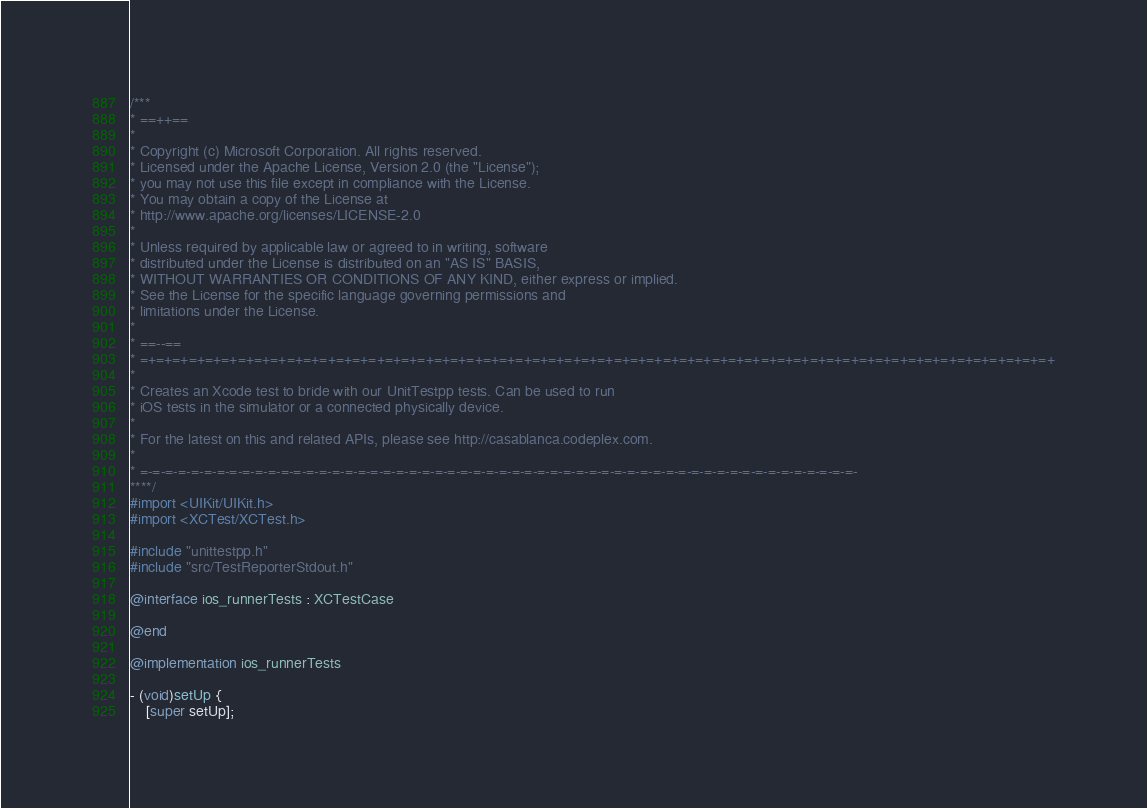<code> <loc_0><loc_0><loc_500><loc_500><_ObjectiveC_>/***
* ==++==
*
* Copyright (c) Microsoft Corporation. All rights reserved.
* Licensed under the Apache License, Version 2.0 (the "License");
* you may not use this file except in compliance with the License.
* You may obtain a copy of the License at
* http://www.apache.org/licenses/LICENSE-2.0
*
* Unless required by applicable law or agreed to in writing, software
* distributed under the License is distributed on an "AS IS" BASIS,
* WITHOUT WARRANTIES OR CONDITIONS OF ANY KIND, either express or implied.
* See the License for the specific language governing permissions and
* limitations under the License.
*
* ==--==
* =+=+=+=+=+=+=+=+=+=+=+=+=+=+=+=+=+=+=+=+=+=+=+=+=+=+=+=+=+=+=+=+=+=+=+=+=+=+=+=+=+=+=+=+=+=+=+=+=+=+=+=+=+=+=+=+
*
* Creates an Xcode test to bride with our UnitTestpp tests. Can be used to run
* iOS tests in the simulator or a connected physically device.
*
* For the latest on this and related APIs, please see http://casablanca.codeplex.com.
*
* =-=-=-=-=-=-=-=-=-=-=-=-=-=-=-=-=-=-=-=-=-=-=-=-=-=-=-=-=-=-=-=-=-=-=-=-=-=-=-=-=-=-=-=-=-=-=-=-=-=-=-=-=-=-=-=-
****/
#import <UIKit/UIKit.h>
#import <XCTest/XCTest.h>

#include "unittestpp.h"
#include "src/TestReporterStdout.h"

@interface ios_runnerTests : XCTestCase

@end

@implementation ios_runnerTests

- (void)setUp {
    [super setUp];</code> 